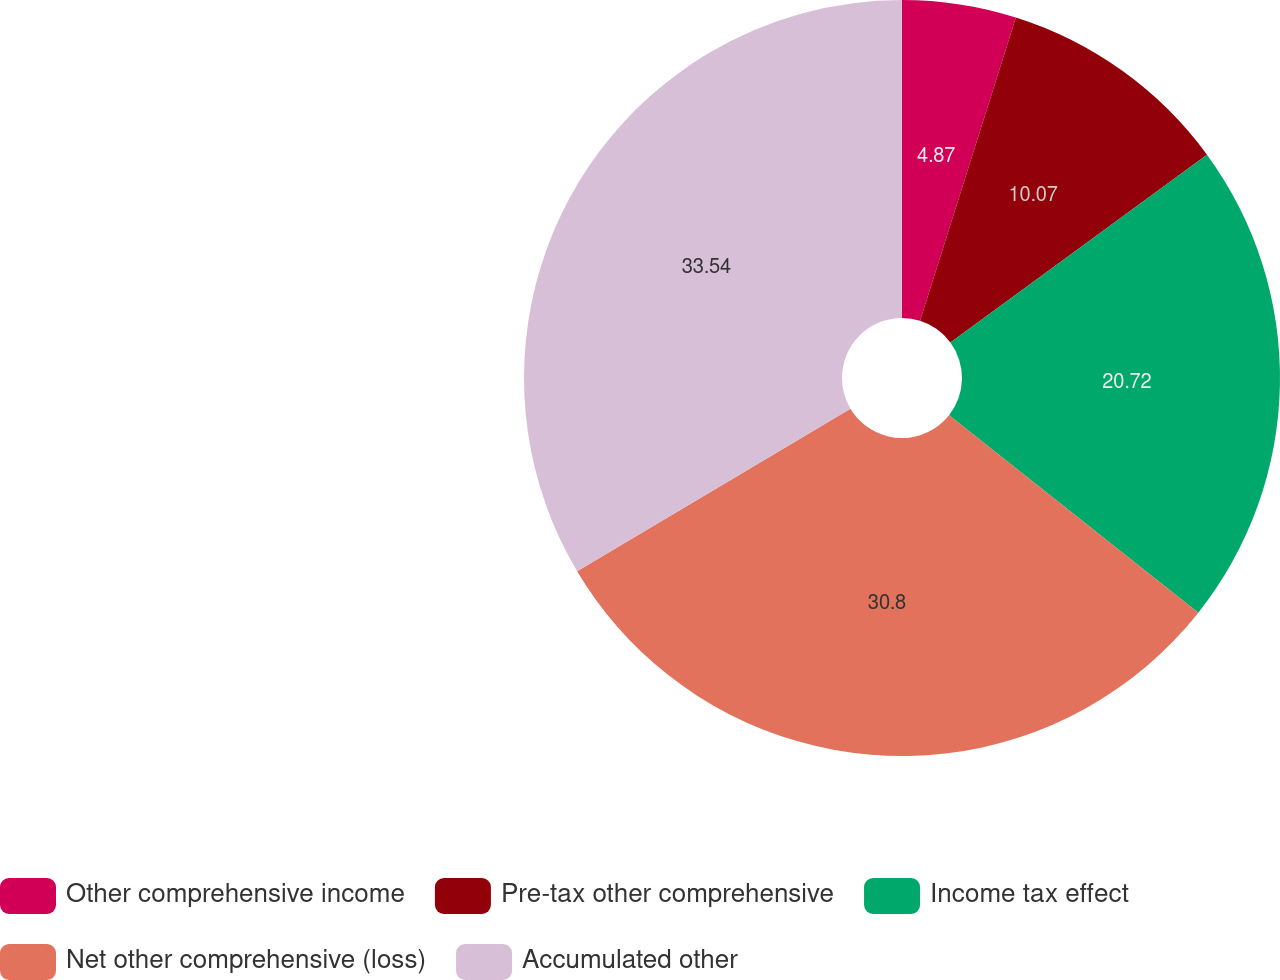Convert chart to OTSL. <chart><loc_0><loc_0><loc_500><loc_500><pie_chart><fcel>Other comprehensive income<fcel>Pre-tax other comprehensive<fcel>Income tax effect<fcel>Net other comprehensive (loss)<fcel>Accumulated other<nl><fcel>4.87%<fcel>10.07%<fcel>20.72%<fcel>30.8%<fcel>33.54%<nl></chart> 